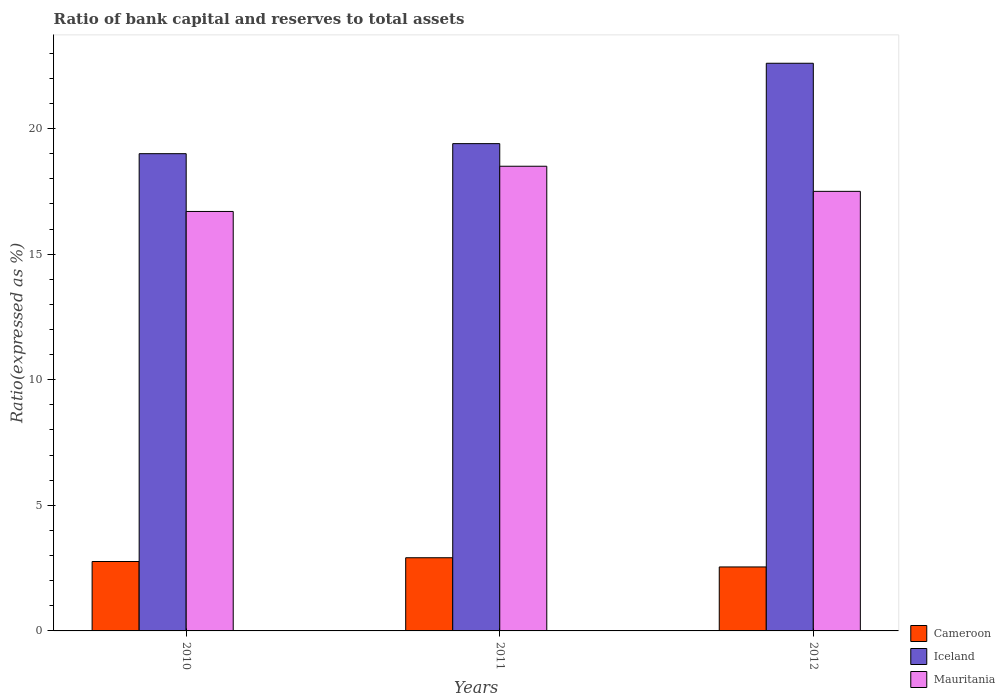How many different coloured bars are there?
Offer a very short reply. 3. How many groups of bars are there?
Ensure brevity in your answer.  3. Are the number of bars on each tick of the X-axis equal?
Offer a very short reply. Yes. How many bars are there on the 3rd tick from the right?
Offer a terse response. 3. What is the label of the 3rd group of bars from the left?
Provide a short and direct response. 2012. What is the ratio of bank capital and reserves to total assets in Iceland in 2011?
Offer a terse response. 19.4. Across all years, what is the maximum ratio of bank capital and reserves to total assets in Mauritania?
Provide a succinct answer. 18.5. In which year was the ratio of bank capital and reserves to total assets in Mauritania maximum?
Your answer should be compact. 2011. In which year was the ratio of bank capital and reserves to total assets in Cameroon minimum?
Keep it short and to the point. 2012. What is the total ratio of bank capital and reserves to total assets in Cameroon in the graph?
Your answer should be compact. 8.22. What is the difference between the ratio of bank capital and reserves to total assets in Iceland in 2010 and that in 2012?
Provide a short and direct response. -3.6. What is the average ratio of bank capital and reserves to total assets in Iceland per year?
Make the answer very short. 20.33. In the year 2011, what is the difference between the ratio of bank capital and reserves to total assets in Cameroon and ratio of bank capital and reserves to total assets in Iceland?
Keep it short and to the point. -16.49. What is the ratio of the ratio of bank capital and reserves to total assets in Cameroon in 2011 to that in 2012?
Offer a very short reply. 1.14. What is the difference between the highest and the second highest ratio of bank capital and reserves to total assets in Iceland?
Your answer should be compact. 3.2. What is the difference between the highest and the lowest ratio of bank capital and reserves to total assets in Iceland?
Make the answer very short. 3.6. Is the sum of the ratio of bank capital and reserves to total assets in Mauritania in 2011 and 2012 greater than the maximum ratio of bank capital and reserves to total assets in Iceland across all years?
Make the answer very short. Yes. What does the 3rd bar from the left in 2010 represents?
Offer a terse response. Mauritania. What does the 1st bar from the right in 2010 represents?
Make the answer very short. Mauritania. Are the values on the major ticks of Y-axis written in scientific E-notation?
Keep it short and to the point. No. Does the graph contain any zero values?
Your response must be concise. No. How are the legend labels stacked?
Ensure brevity in your answer.  Vertical. What is the title of the graph?
Your answer should be very brief. Ratio of bank capital and reserves to total assets. Does "East Asia (all income levels)" appear as one of the legend labels in the graph?
Your answer should be compact. No. What is the label or title of the X-axis?
Make the answer very short. Years. What is the label or title of the Y-axis?
Offer a very short reply. Ratio(expressed as %). What is the Ratio(expressed as %) in Cameroon in 2010?
Provide a short and direct response. 2.76. What is the Ratio(expressed as %) of Cameroon in 2011?
Provide a succinct answer. 2.91. What is the Ratio(expressed as %) of Iceland in 2011?
Your answer should be compact. 19.4. What is the Ratio(expressed as %) in Mauritania in 2011?
Ensure brevity in your answer.  18.5. What is the Ratio(expressed as %) in Cameroon in 2012?
Your answer should be very brief. 2.55. What is the Ratio(expressed as %) of Iceland in 2012?
Your answer should be compact. 22.6. Across all years, what is the maximum Ratio(expressed as %) of Cameroon?
Offer a terse response. 2.91. Across all years, what is the maximum Ratio(expressed as %) of Iceland?
Your answer should be very brief. 22.6. Across all years, what is the minimum Ratio(expressed as %) in Cameroon?
Provide a succinct answer. 2.55. Across all years, what is the minimum Ratio(expressed as %) of Iceland?
Your answer should be compact. 19. Across all years, what is the minimum Ratio(expressed as %) in Mauritania?
Keep it short and to the point. 16.7. What is the total Ratio(expressed as %) of Cameroon in the graph?
Give a very brief answer. 8.22. What is the total Ratio(expressed as %) in Iceland in the graph?
Make the answer very short. 61. What is the total Ratio(expressed as %) of Mauritania in the graph?
Offer a terse response. 52.7. What is the difference between the Ratio(expressed as %) of Cameroon in 2010 and that in 2011?
Keep it short and to the point. -0.15. What is the difference between the Ratio(expressed as %) in Mauritania in 2010 and that in 2011?
Your answer should be compact. -1.8. What is the difference between the Ratio(expressed as %) of Cameroon in 2010 and that in 2012?
Your answer should be compact. 0.22. What is the difference between the Ratio(expressed as %) of Mauritania in 2010 and that in 2012?
Provide a short and direct response. -0.8. What is the difference between the Ratio(expressed as %) of Cameroon in 2011 and that in 2012?
Offer a very short reply. 0.37. What is the difference between the Ratio(expressed as %) in Iceland in 2011 and that in 2012?
Keep it short and to the point. -3.2. What is the difference between the Ratio(expressed as %) in Mauritania in 2011 and that in 2012?
Keep it short and to the point. 1. What is the difference between the Ratio(expressed as %) in Cameroon in 2010 and the Ratio(expressed as %) in Iceland in 2011?
Offer a terse response. -16.64. What is the difference between the Ratio(expressed as %) of Cameroon in 2010 and the Ratio(expressed as %) of Mauritania in 2011?
Offer a very short reply. -15.74. What is the difference between the Ratio(expressed as %) in Iceland in 2010 and the Ratio(expressed as %) in Mauritania in 2011?
Your answer should be very brief. 0.5. What is the difference between the Ratio(expressed as %) in Cameroon in 2010 and the Ratio(expressed as %) in Iceland in 2012?
Provide a short and direct response. -19.84. What is the difference between the Ratio(expressed as %) in Cameroon in 2010 and the Ratio(expressed as %) in Mauritania in 2012?
Offer a very short reply. -14.74. What is the difference between the Ratio(expressed as %) of Iceland in 2010 and the Ratio(expressed as %) of Mauritania in 2012?
Keep it short and to the point. 1.5. What is the difference between the Ratio(expressed as %) in Cameroon in 2011 and the Ratio(expressed as %) in Iceland in 2012?
Your answer should be compact. -19.69. What is the difference between the Ratio(expressed as %) in Cameroon in 2011 and the Ratio(expressed as %) in Mauritania in 2012?
Make the answer very short. -14.59. What is the difference between the Ratio(expressed as %) of Iceland in 2011 and the Ratio(expressed as %) of Mauritania in 2012?
Your answer should be very brief. 1.9. What is the average Ratio(expressed as %) in Cameroon per year?
Provide a succinct answer. 2.74. What is the average Ratio(expressed as %) in Iceland per year?
Offer a terse response. 20.33. What is the average Ratio(expressed as %) in Mauritania per year?
Give a very brief answer. 17.57. In the year 2010, what is the difference between the Ratio(expressed as %) in Cameroon and Ratio(expressed as %) in Iceland?
Provide a succinct answer. -16.24. In the year 2010, what is the difference between the Ratio(expressed as %) of Cameroon and Ratio(expressed as %) of Mauritania?
Your answer should be very brief. -13.94. In the year 2011, what is the difference between the Ratio(expressed as %) in Cameroon and Ratio(expressed as %) in Iceland?
Make the answer very short. -16.49. In the year 2011, what is the difference between the Ratio(expressed as %) of Cameroon and Ratio(expressed as %) of Mauritania?
Provide a short and direct response. -15.59. In the year 2012, what is the difference between the Ratio(expressed as %) of Cameroon and Ratio(expressed as %) of Iceland?
Your answer should be compact. -20.05. In the year 2012, what is the difference between the Ratio(expressed as %) in Cameroon and Ratio(expressed as %) in Mauritania?
Keep it short and to the point. -14.95. What is the ratio of the Ratio(expressed as %) in Cameroon in 2010 to that in 2011?
Ensure brevity in your answer.  0.95. What is the ratio of the Ratio(expressed as %) in Iceland in 2010 to that in 2011?
Make the answer very short. 0.98. What is the ratio of the Ratio(expressed as %) in Mauritania in 2010 to that in 2011?
Your response must be concise. 0.9. What is the ratio of the Ratio(expressed as %) of Cameroon in 2010 to that in 2012?
Keep it short and to the point. 1.08. What is the ratio of the Ratio(expressed as %) in Iceland in 2010 to that in 2012?
Provide a short and direct response. 0.84. What is the ratio of the Ratio(expressed as %) in Mauritania in 2010 to that in 2012?
Provide a short and direct response. 0.95. What is the ratio of the Ratio(expressed as %) in Cameroon in 2011 to that in 2012?
Offer a terse response. 1.14. What is the ratio of the Ratio(expressed as %) of Iceland in 2011 to that in 2012?
Ensure brevity in your answer.  0.86. What is the ratio of the Ratio(expressed as %) in Mauritania in 2011 to that in 2012?
Ensure brevity in your answer.  1.06. What is the difference between the highest and the second highest Ratio(expressed as %) in Cameroon?
Ensure brevity in your answer.  0.15. What is the difference between the highest and the lowest Ratio(expressed as %) in Cameroon?
Keep it short and to the point. 0.37. What is the difference between the highest and the lowest Ratio(expressed as %) of Iceland?
Keep it short and to the point. 3.6. 